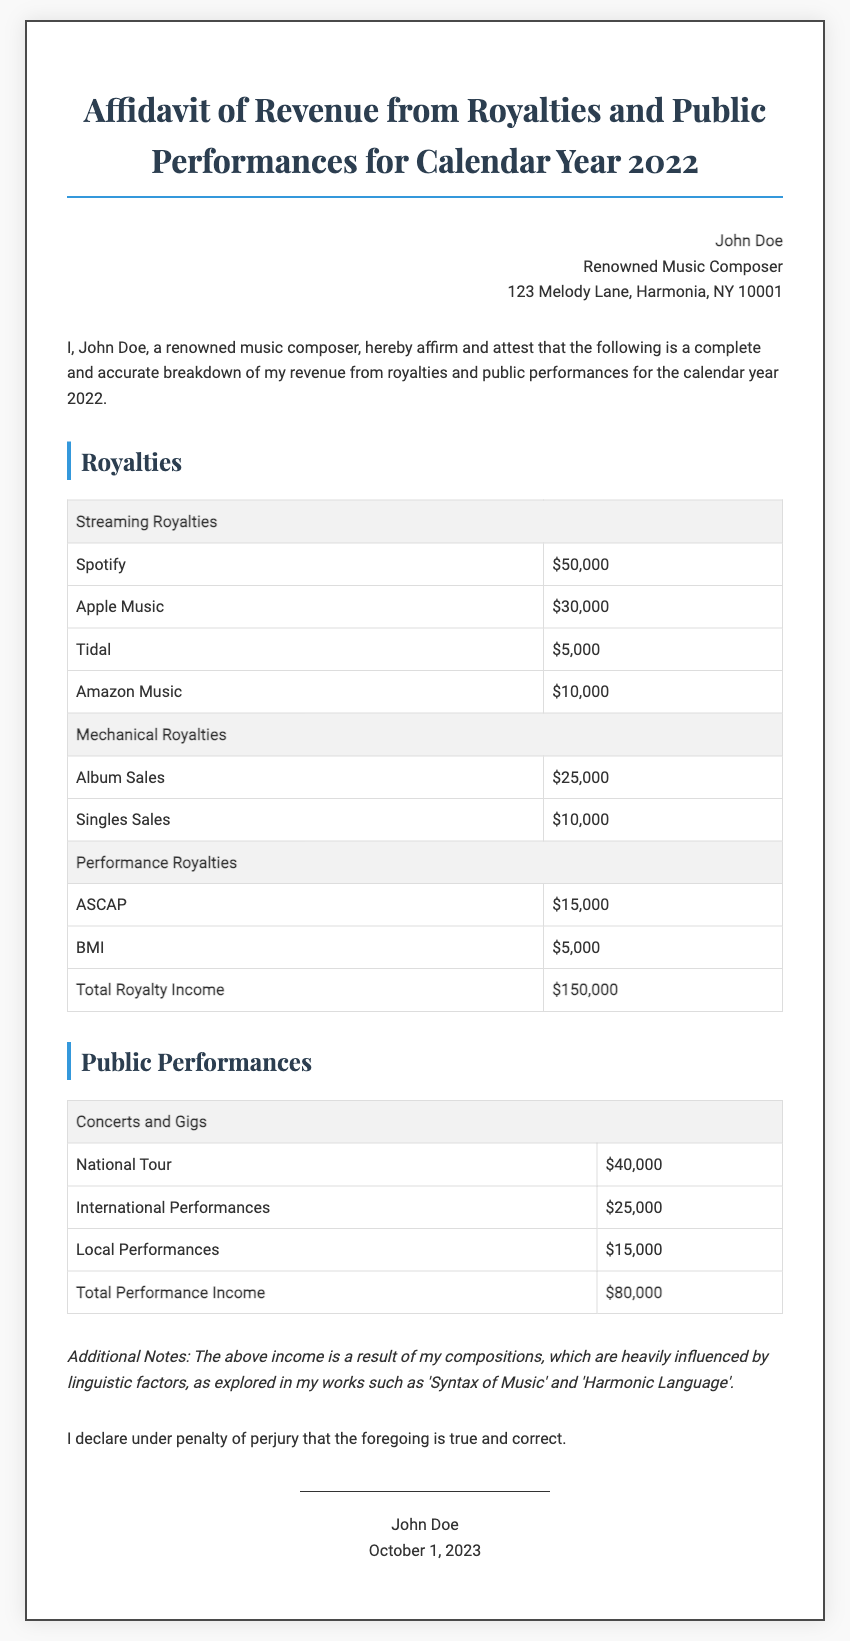What is the name of the affiant? The affiant is the individual who signs the affidavit, which in this case is John Doe.
Answer: John Doe What is the total royalty income? The total royalty income is listed as a summary in the document, which combines all sources of royalty income.
Answer: $150,000 How much was earned from international performances? The document provides a specific breakdown of income sources, including a category for international performances.
Answer: $25,000 What date is the affidavit signed? The signature section contains the date when the affidavit is signed by the affiant.
Answer: October 1, 2023 What is the total performance income? The document includes a total for performance income, which is derived from the concerts and gigs.
Answer: $80,000 What is the primary focus of the additional notes? The additional notes refer to the influence of linguistic factors on the affiant's compositions.
Answer: Linguistic factors What type of document is this? The document is specifically described as an affidavit related to revenue from royalties and public performances.
Answer: Affidavit How many sources of streaming royalties are listed? The portion of the document detailing streaming royalties lists each source, which can be counted.
Answer: 4 